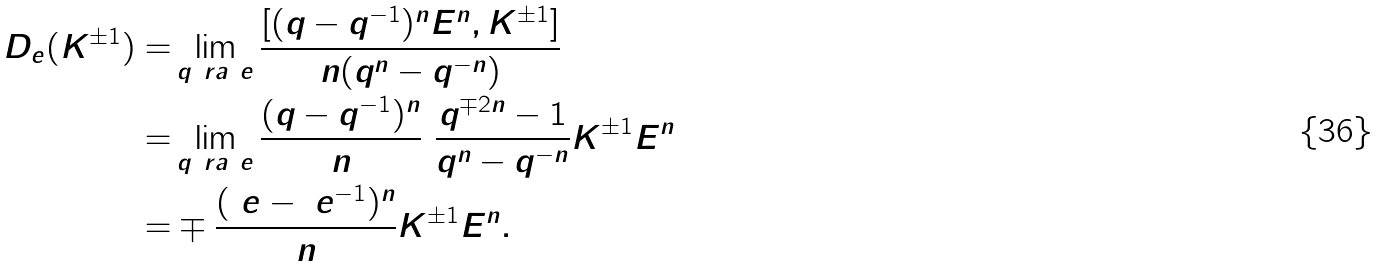<formula> <loc_0><loc_0><loc_500><loc_500>D _ { e } ( K ^ { \pm 1 } ) = & \lim _ { q \ r a \ e } \frac { [ ( q - q ^ { - 1 } ) ^ { n } E ^ { n } , K ^ { \pm 1 } ] } { n ( q ^ { n } - q ^ { - n } ) } \\ = & \lim _ { q \ r a \ e } \frac { ( q - q ^ { - 1 } ) ^ { n } } { n } \ \frac { q ^ { \mp 2 n } - 1 } { q ^ { n } - q ^ { - n } } K ^ { \pm 1 } E ^ { n } \\ = & \mp \frac { ( \ e - \ e ^ { - 1 } ) ^ { n } } { n } K ^ { \pm 1 } E ^ { n } .</formula> 